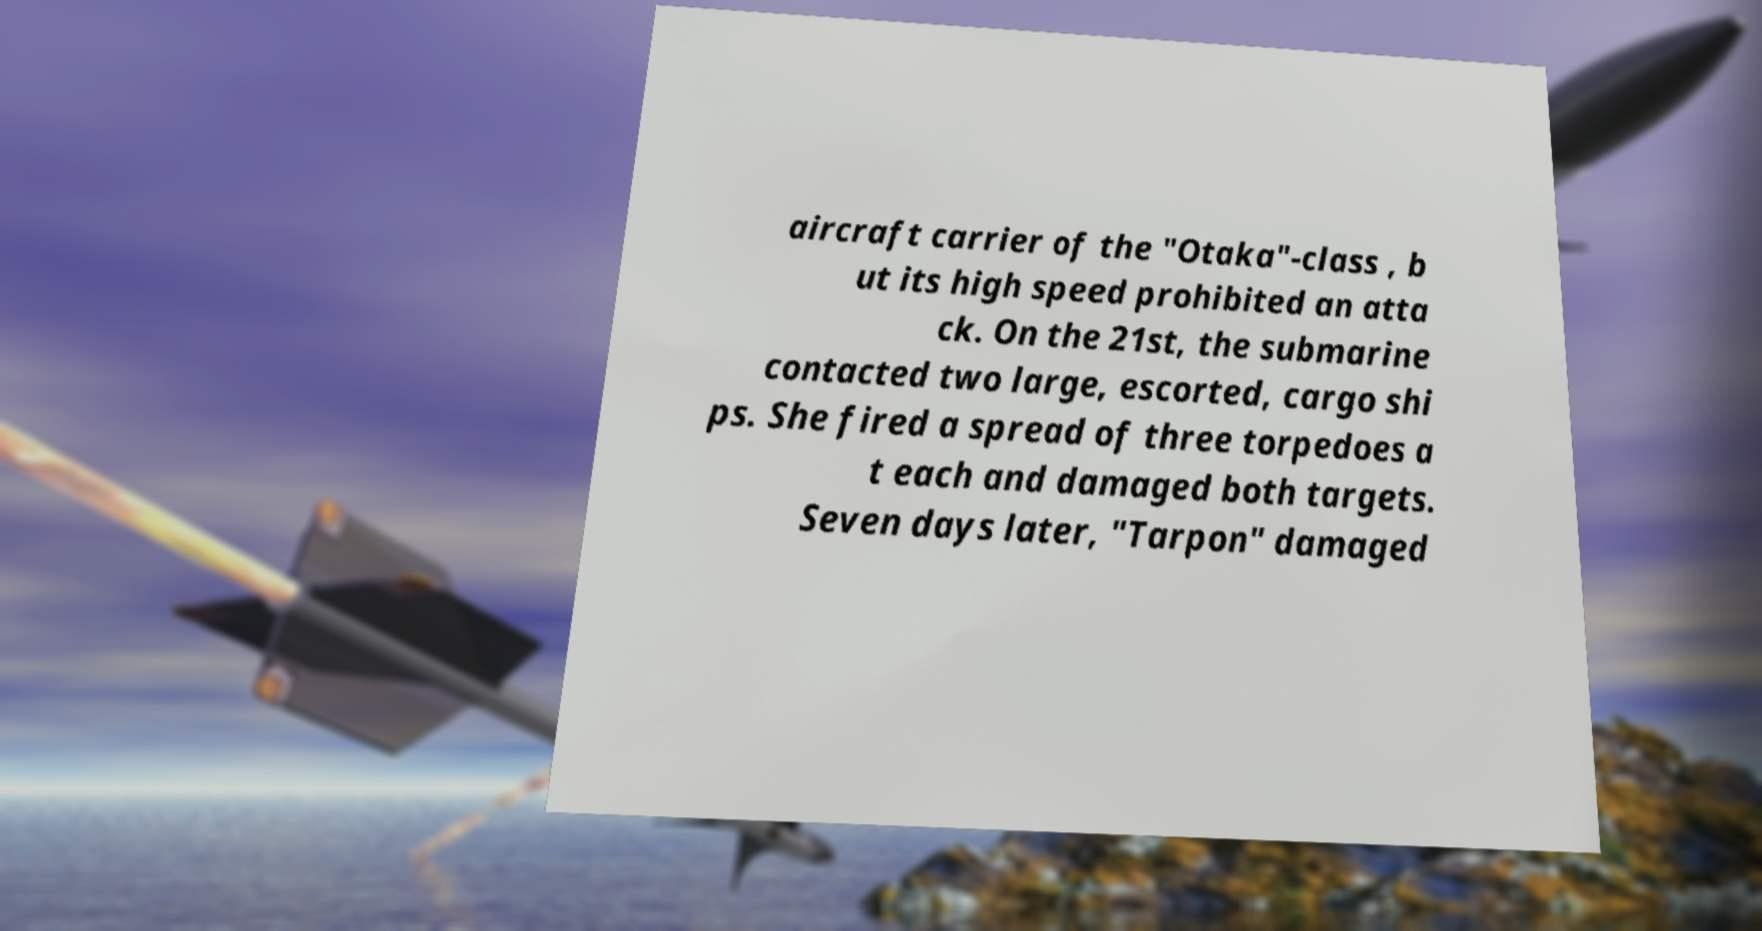For documentation purposes, I need the text within this image transcribed. Could you provide that? aircraft carrier of the "Otaka"-class , b ut its high speed prohibited an atta ck. On the 21st, the submarine contacted two large, escorted, cargo shi ps. She fired a spread of three torpedoes a t each and damaged both targets. Seven days later, "Tarpon" damaged 